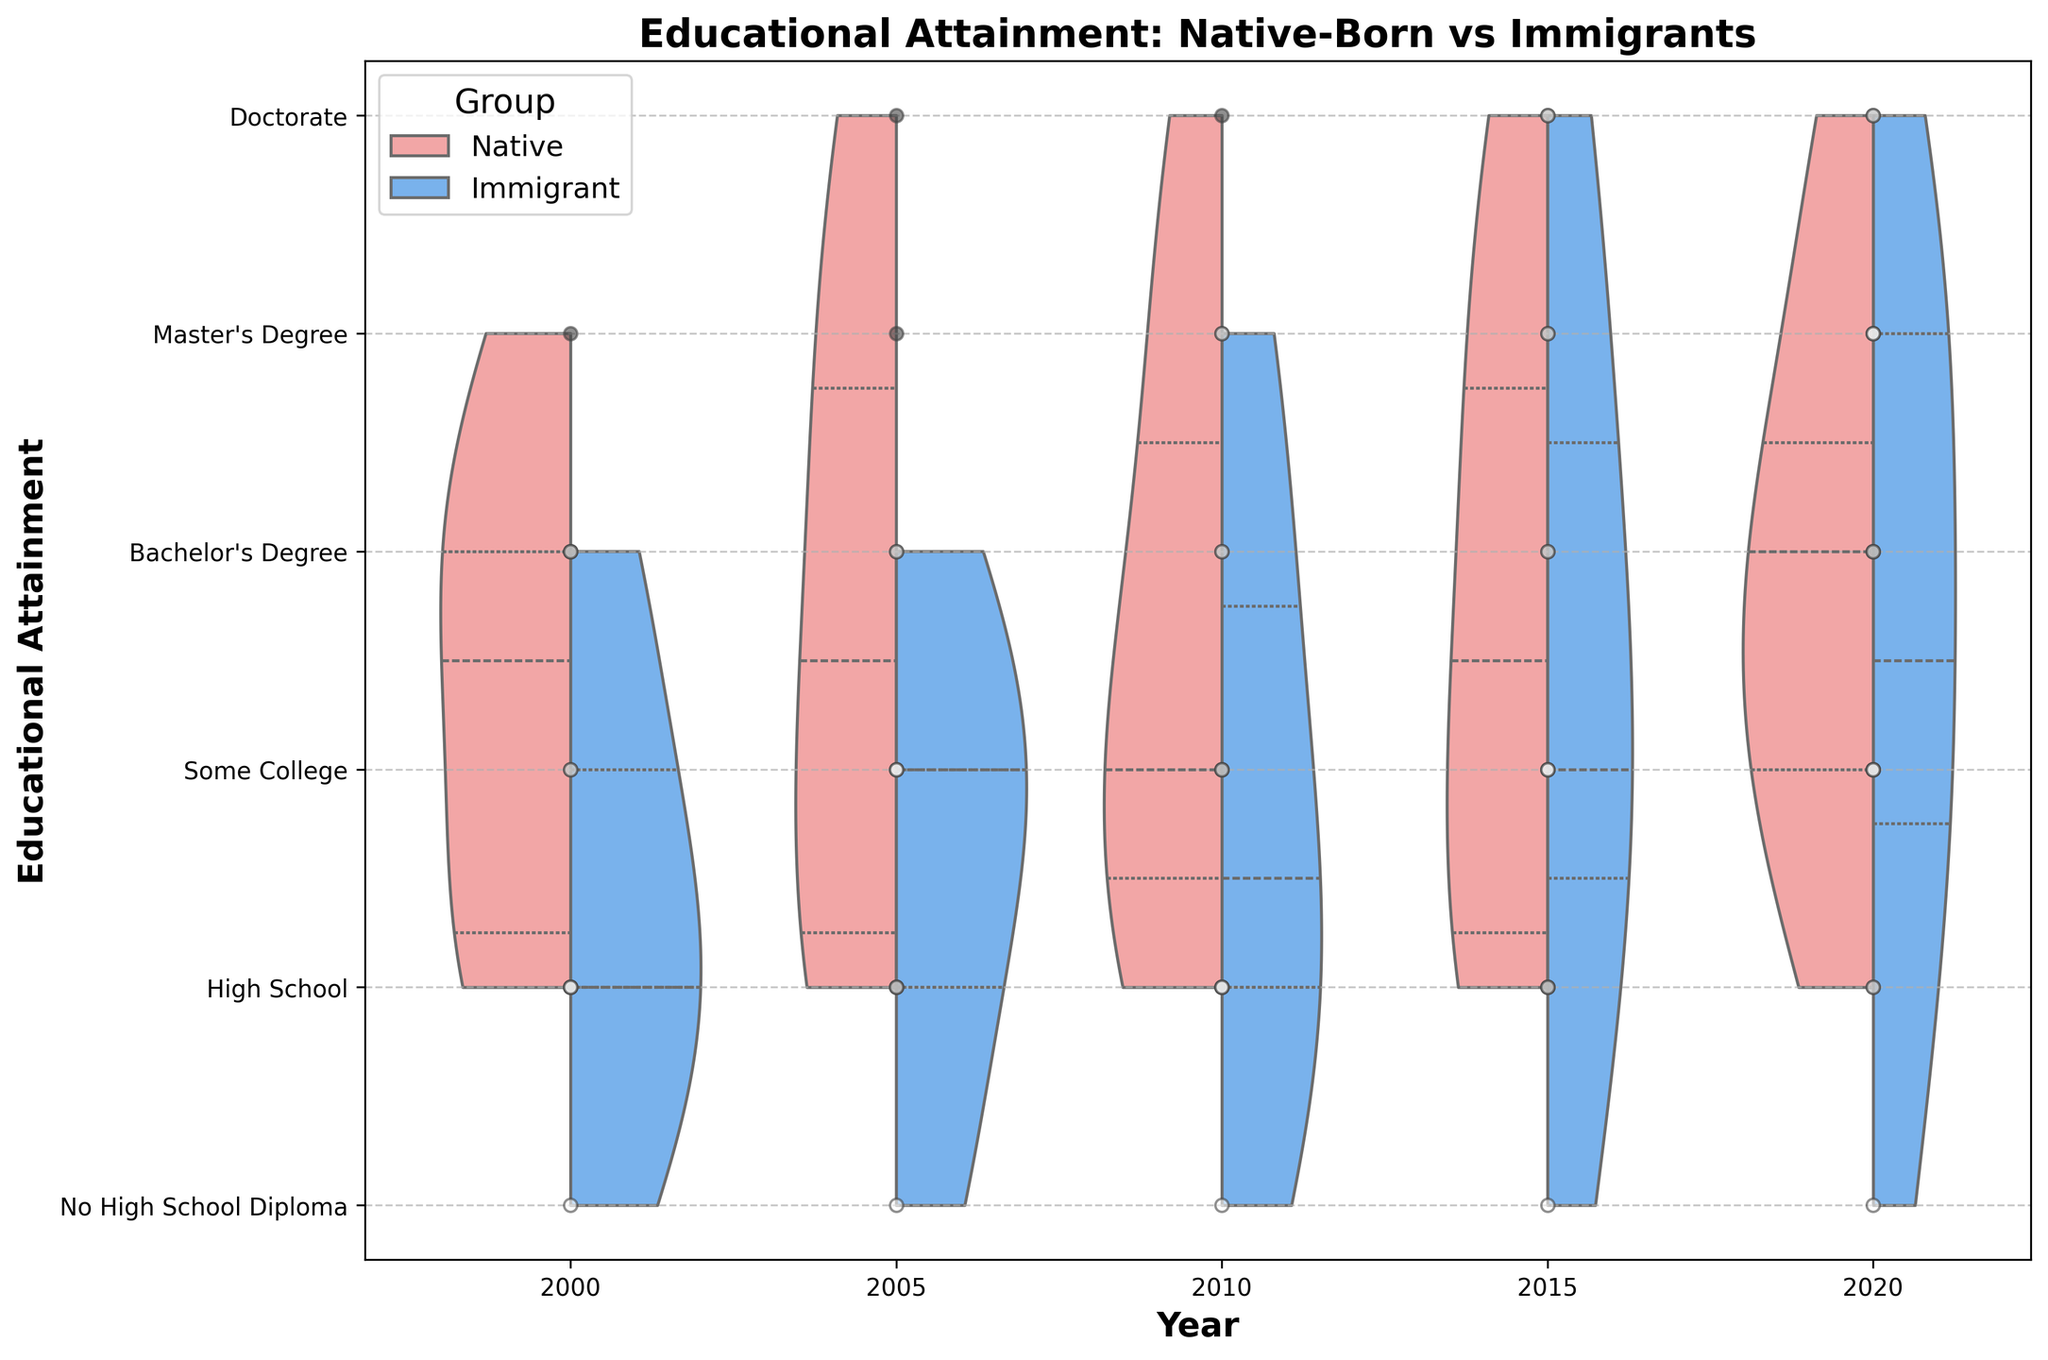What is the title of the figure? The title is located at the top of the figure, typically in a larger or bold font for emphasis. In this case, it reads "Educational Attainment: Native-Born vs Immigrants."
Answer: Educational Attainment: Native-Born vs Immigrants What are the categories of educational attainment shown on the y-axis? The y-axis labels represent different levels of educational attainment. They are: "No High School Diploma," "High School," "Some College," "Bachelor's Degree," "Master's Degree," and "Doctorate."
Answer: No High School Diploma, High School, Some College, Bachelor's Degree, Master's Degree, Doctorate How is the data differentiated between groups in the plot? The plot differentiates between native-born citizens and immigrants using different colors and patterns. Native-born citizens are represented by a lighter color, while immigrants are shown in a different color. Additionally, jittered points may have different colors.
Answer: By color and point style Which group shows a higher prevalence of higher educational attainment in 2020? By examining the 2020 section of the plot, we notice where the densities and jittered points concentrate. Native-born citizens show a higher prevalence in Bachelor's degrees and above compared to immigrants.
Answer: Native-born citizens How does the median educational attainment for immigrants change from 2000 to 2020? By looking at the inner quartile lines within the violins, we observe the median educational levels. The median for immigrants improves over time, moving from closer to "High School" in 2000 to "Some College" in 2020.
Answer: Improves from High School to Some College Which group shows more dispersion in educational attainment in 2015? Dispersion in a violin plot is indicated by the spread of the violin. In 2015, the spread is wider for immigrants, indicating more dispersion in educational attainment compared to native-born citizens.
Answer: Immigrants Are there any overlapping educational levels for native-born citizens and immigrants in 2005? By examining the plot for 2005, we look for areas where the violins of both groups overlap. Both groups show overlap in "High School," "Some College," and "Bachelor’s Degree," indicating they share these educational levels.
Answer: Yes, overlap in High School, Some College, and Bachelor's Degree What is the primary educational attainment level for native-born citizens in 2010? For 2010, we observe where the density in the violin plot is highest for native-born citizens. The primary level is "High School," as this is where most of the points and higher density are concentrated.
Answer: High School Considering the overall trend, do native-born citizens or immigrants show more improvement in educational attainment over the years? By comparing the changes in densities and median levels over the years from 2000 to 2020, we see that immigrants move from lower educational levels towards higher levels more significantly than native-born citizens.
Answer: Immigrants 